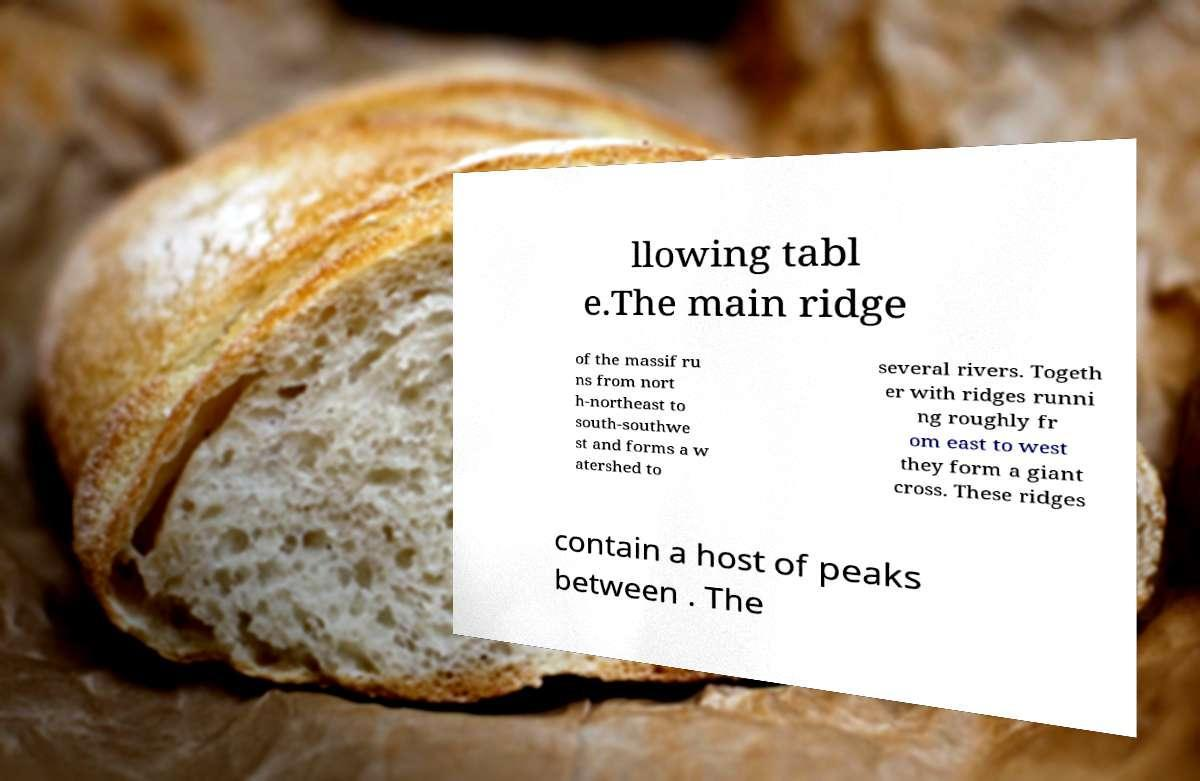Could you assist in decoding the text presented in this image and type it out clearly? llowing tabl e.The main ridge of the massif ru ns from nort h-northeast to south-southwe st and forms a w atershed to several rivers. Togeth er with ridges runni ng roughly fr om east to west they form a giant cross. These ridges contain a host of peaks between . The 